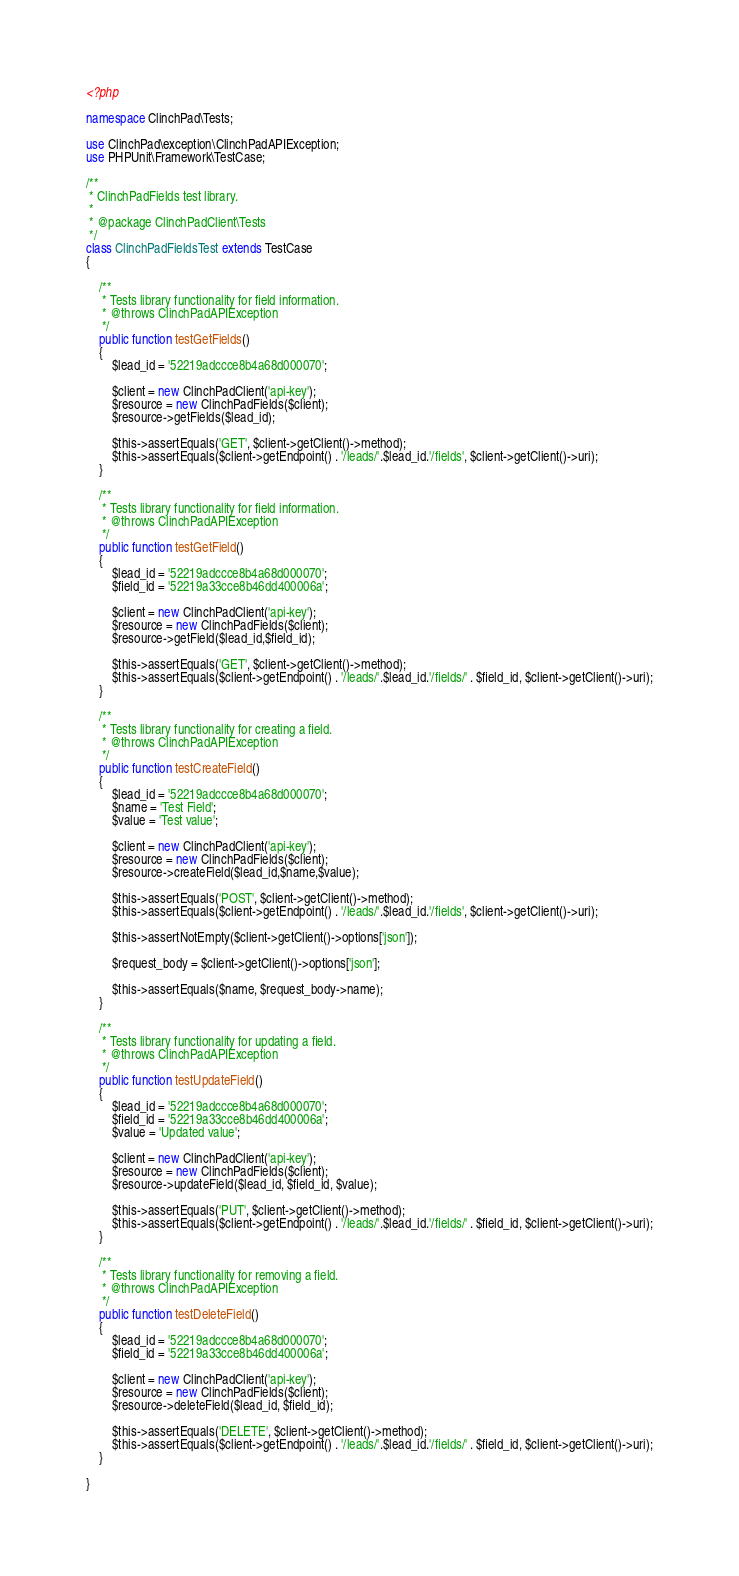Convert code to text. <code><loc_0><loc_0><loc_500><loc_500><_PHP_><?php

namespace ClinchPad\Tests;

use ClinchPad\exception\ClinchPadAPIException;
use PHPUnit\Framework\TestCase;

/**
 * ClinchPadFields test library.
 *
 * @package ClinchPadClient\Tests
 */
class ClinchPadFieldsTest extends TestCase
{

    /**
     * Tests library functionality for field information.
     * @throws ClinchPadAPIException
     */
    public function testGetFields()
    {
        $lead_id = '52219adccce8b4a68d000070';

        $client = new ClinchPadClient('api-key');
        $resource = new ClinchPadFields($client);
        $resource->getFields($lead_id);

        $this->assertEquals('GET', $client->getClient()->method);
        $this->assertEquals($client->getEndpoint() . '/leads/'.$lead_id.'/fields', $client->getClient()->uri);
    }

    /**
     * Tests library functionality for field information.
     * @throws ClinchPadAPIException
     */
    public function testGetField()
    {
        $lead_id = '52219adccce8b4a68d000070';
        $field_id = '52219a33cce8b46dd400006a';

        $client = new ClinchPadClient('api-key');
        $resource = new ClinchPadFields($client);
        $resource->getField($lead_id,$field_id);

        $this->assertEquals('GET', $client->getClient()->method);
        $this->assertEquals($client->getEndpoint() . '/leads/'.$lead_id.'/fields/' . $field_id, $client->getClient()->uri);
    }

    /**
     * Tests library functionality for creating a field.
     * @throws ClinchPadAPIException
     */
    public function testCreateField()
    {
        $lead_id = '52219adccce8b4a68d000070';
        $name = 'Test Field';
        $value = 'Test value';

        $client = new ClinchPadClient('api-key');
        $resource = new ClinchPadFields($client);
        $resource->createField($lead_id,$name,$value);

        $this->assertEquals('POST', $client->getClient()->method);
        $this->assertEquals($client->getEndpoint() . '/leads/'.$lead_id.'/fields', $client->getClient()->uri);

        $this->assertNotEmpty($client->getClient()->options['json']);

        $request_body = $client->getClient()->options['json'];

        $this->assertEquals($name, $request_body->name);
    }

    /**
     * Tests library functionality for updating a field.
     * @throws ClinchPadAPIException
     */
    public function testUpdateField()
    {
        $lead_id = '52219adccce8b4a68d000070';
        $field_id = '52219a33cce8b46dd400006a';
        $value = 'Updated value';

        $client = new ClinchPadClient('api-key');
        $resource = new ClinchPadFields($client);
        $resource->updateField($lead_id, $field_id, $value);

        $this->assertEquals('PUT', $client->getClient()->method);
        $this->assertEquals($client->getEndpoint() . '/leads/'.$lead_id.'/fields/' . $field_id, $client->getClient()->uri);
    }

    /**
     * Tests library functionality for removing a field.
     * @throws ClinchPadAPIException
     */
    public function testDeleteField()
    {
        $lead_id = '52219adccce8b4a68d000070';
        $field_id = '52219a33cce8b46dd400006a';

        $client = new ClinchPadClient('api-key');
        $resource = new ClinchPadFields($client);
        $resource->deleteField($lead_id, $field_id);

        $this->assertEquals('DELETE', $client->getClient()->method);
        $this->assertEquals($client->getEndpoint() . '/leads/'.$lead_id.'/fields/' . $field_id, $client->getClient()->uri);
    }

}
</code> 